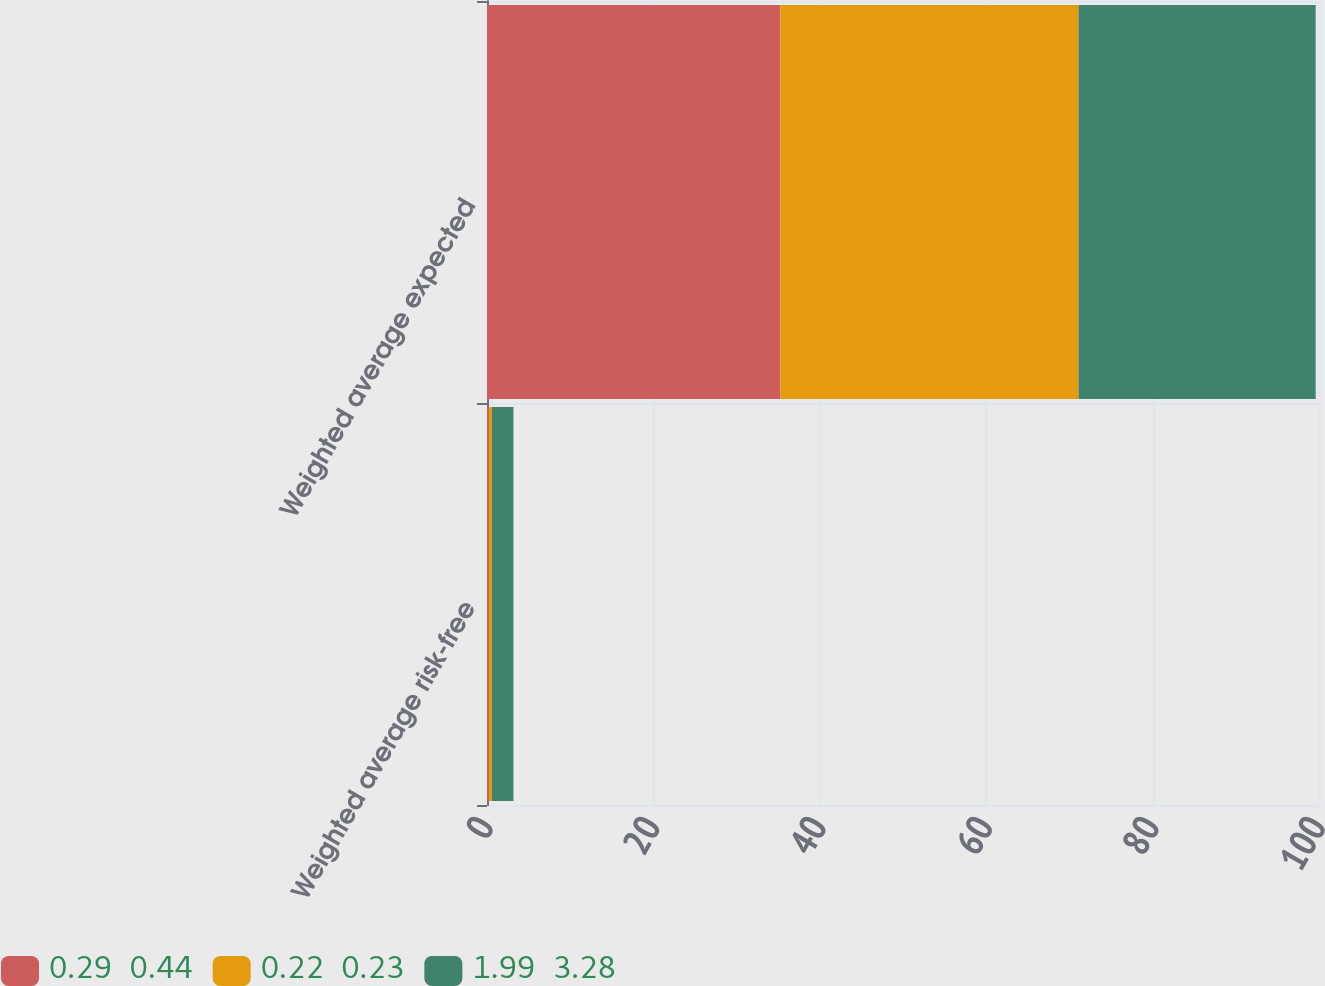Convert chart. <chart><loc_0><loc_0><loc_500><loc_500><stacked_bar_chart><ecel><fcel>Weighted average risk-free<fcel>Weighted average expected<nl><fcel>0.29  0.44<fcel>0.22<fcel>35.26<nl><fcel>0.22  0.23<fcel>0.38<fcel>35.83<nl><fcel>1.99  3.28<fcel>2.58<fcel>28.51<nl></chart> 